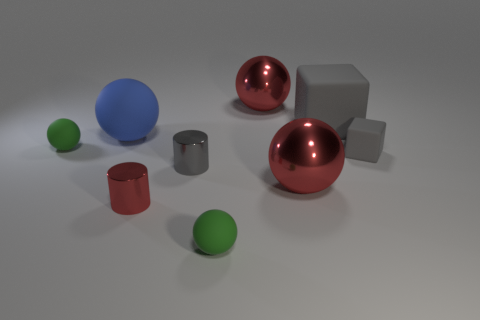Subtract all blue spheres. How many spheres are left? 4 Subtract all large matte balls. How many balls are left? 4 Subtract all cyan balls. Subtract all green cylinders. How many balls are left? 5 Add 1 rubber objects. How many objects exist? 10 Subtract all cubes. How many objects are left? 7 Subtract all small matte blocks. Subtract all gray cylinders. How many objects are left? 7 Add 5 red shiny balls. How many red shiny balls are left? 7 Add 6 matte blocks. How many matte blocks exist? 8 Subtract 0 purple cylinders. How many objects are left? 9 